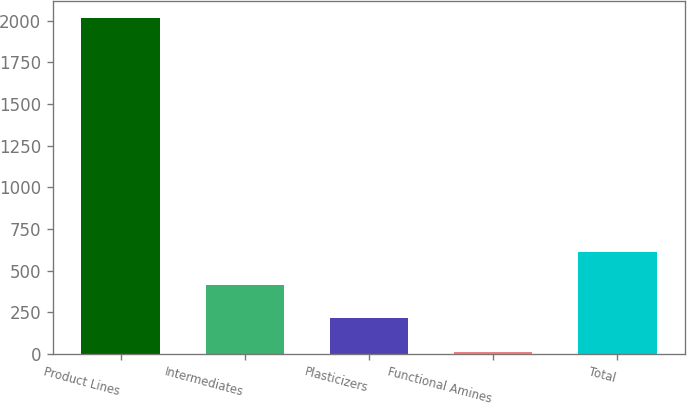Convert chart to OTSL. <chart><loc_0><loc_0><loc_500><loc_500><bar_chart><fcel>Product Lines<fcel>Intermediates<fcel>Plasticizers<fcel>Functional Amines<fcel>Total<nl><fcel>2015<fcel>415<fcel>215<fcel>15<fcel>615<nl></chart> 